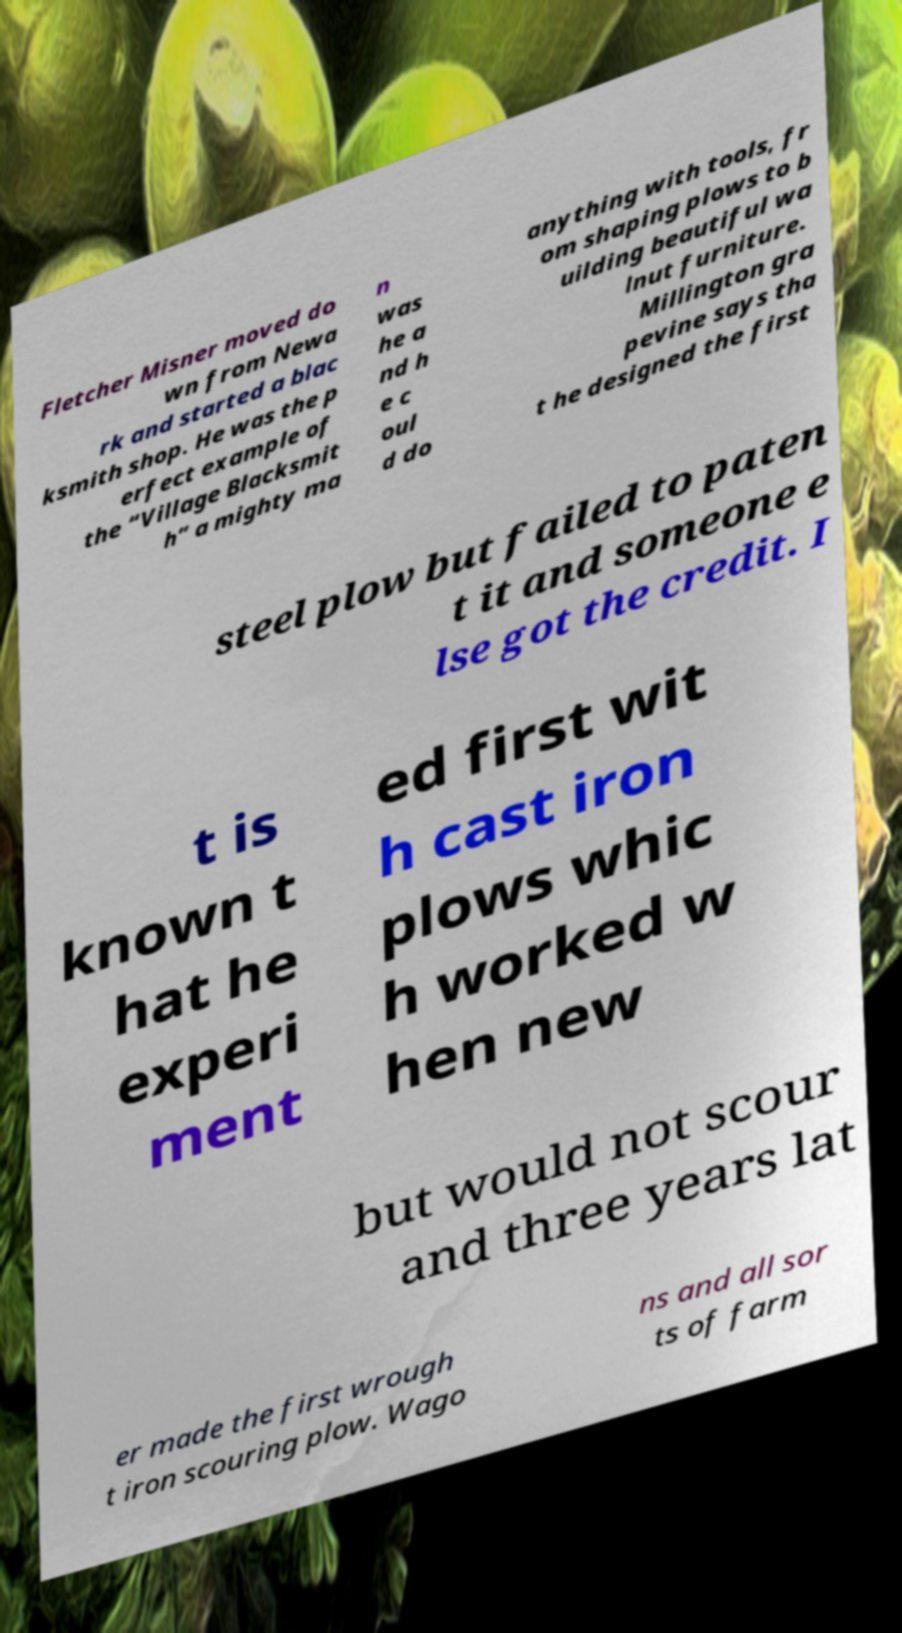Please identify and transcribe the text found in this image. Fletcher Misner moved do wn from Newa rk and started a blac ksmith shop. He was the p erfect example of the “Village Blacksmit h” a mighty ma n was he a nd h e c oul d do anything with tools, fr om shaping plows to b uilding beautiful wa lnut furniture. Millington gra pevine says tha t he designed the first steel plow but failed to paten t it and someone e lse got the credit. I t is known t hat he experi ment ed first wit h cast iron plows whic h worked w hen new but would not scour and three years lat er made the first wrough t iron scouring plow. Wago ns and all sor ts of farm 